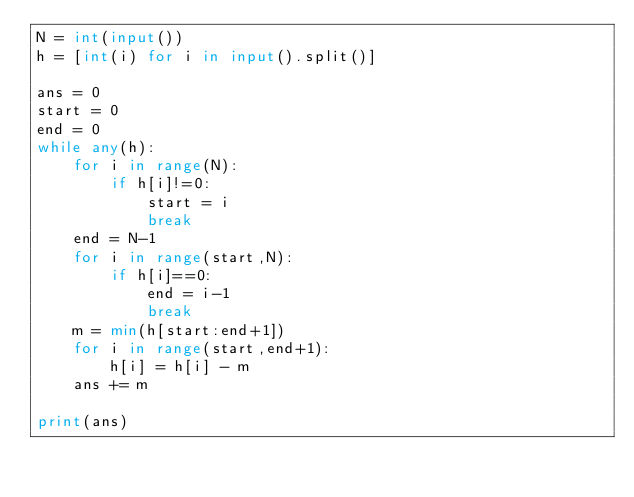Convert code to text. <code><loc_0><loc_0><loc_500><loc_500><_Python_>N = int(input())
h = [int(i) for i in input().split()]

ans = 0
start = 0
end = 0
while any(h):
    for i in range(N):
        if h[i]!=0:
            start = i
            break
    end = N-1
    for i in range(start,N):
        if h[i]==0:
            end = i-1
            break
    m = min(h[start:end+1])
    for i in range(start,end+1):
        h[i] = h[i] - m
    ans += m

print(ans)
</code> 